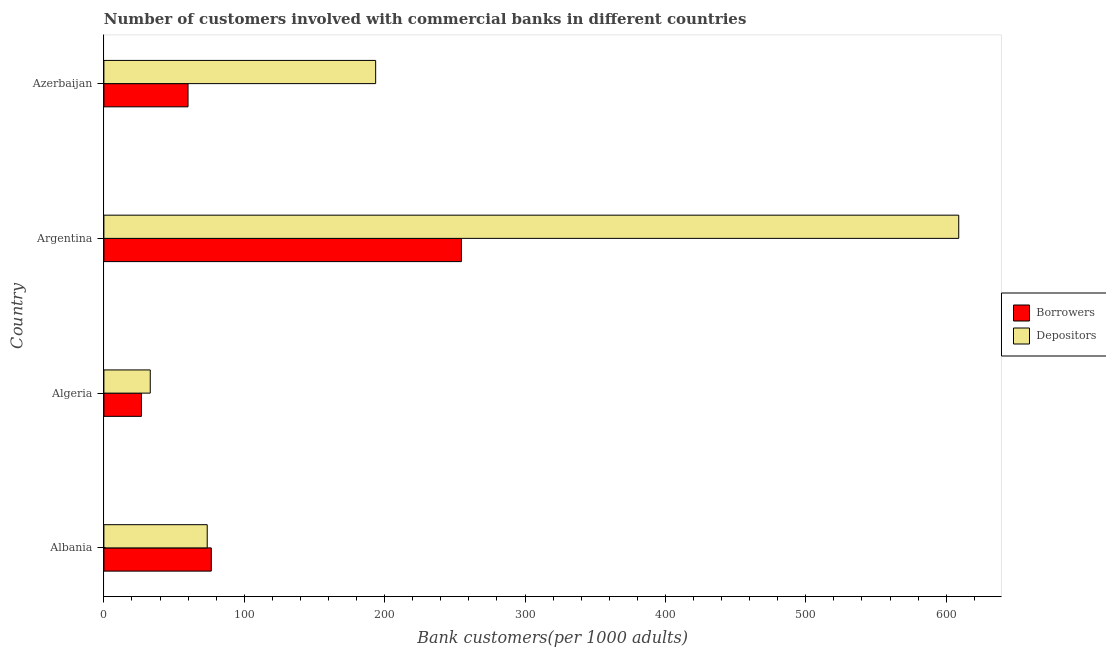How many groups of bars are there?
Your response must be concise. 4. Are the number of bars per tick equal to the number of legend labels?
Make the answer very short. Yes. What is the label of the 1st group of bars from the top?
Your response must be concise. Azerbaijan. What is the number of borrowers in Azerbaijan?
Offer a very short reply. 59.93. Across all countries, what is the maximum number of borrowers?
Offer a terse response. 254.69. Across all countries, what is the minimum number of borrowers?
Offer a terse response. 26.77. In which country was the number of borrowers maximum?
Provide a succinct answer. Argentina. In which country was the number of depositors minimum?
Your response must be concise. Algeria. What is the total number of depositors in the graph?
Your answer should be very brief. 909.13. What is the difference between the number of depositors in Albania and that in Azerbaijan?
Provide a short and direct response. -119.99. What is the difference between the number of borrowers in Albania and the number of depositors in Azerbaijan?
Your response must be concise. -117.09. What is the average number of depositors per country?
Your answer should be very brief. 227.28. What is the difference between the number of borrowers and number of depositors in Azerbaijan?
Offer a very short reply. -133.66. In how many countries, is the number of borrowers greater than 420 ?
Provide a short and direct response. 0. What is the ratio of the number of depositors in Albania to that in Algeria?
Your response must be concise. 2.23. Is the number of borrowers in Argentina less than that in Azerbaijan?
Provide a short and direct response. No. Is the difference between the number of depositors in Algeria and Azerbaijan greater than the difference between the number of borrowers in Algeria and Azerbaijan?
Keep it short and to the point. No. What is the difference between the highest and the second highest number of depositors?
Provide a short and direct response. 415.34. What is the difference between the highest and the lowest number of borrowers?
Offer a very short reply. 227.92. What does the 2nd bar from the top in Argentina represents?
Ensure brevity in your answer.  Borrowers. What does the 2nd bar from the bottom in Albania represents?
Your answer should be very brief. Depositors. How many countries are there in the graph?
Give a very brief answer. 4. Does the graph contain grids?
Offer a terse response. No. How many legend labels are there?
Offer a very short reply. 2. What is the title of the graph?
Your answer should be compact. Number of customers involved with commercial banks in different countries. Does "Travel services" appear as one of the legend labels in the graph?
Your answer should be compact. No. What is the label or title of the X-axis?
Provide a short and direct response. Bank customers(per 1000 adults). What is the Bank customers(per 1000 adults) of Borrowers in Albania?
Your answer should be very brief. 76.5. What is the Bank customers(per 1000 adults) of Depositors in Albania?
Offer a very short reply. 73.6. What is the Bank customers(per 1000 adults) of Borrowers in Algeria?
Offer a terse response. 26.77. What is the Bank customers(per 1000 adults) in Depositors in Algeria?
Provide a short and direct response. 33.02. What is the Bank customers(per 1000 adults) of Borrowers in Argentina?
Keep it short and to the point. 254.69. What is the Bank customers(per 1000 adults) in Depositors in Argentina?
Your response must be concise. 608.93. What is the Bank customers(per 1000 adults) of Borrowers in Azerbaijan?
Keep it short and to the point. 59.93. What is the Bank customers(per 1000 adults) of Depositors in Azerbaijan?
Ensure brevity in your answer.  193.59. Across all countries, what is the maximum Bank customers(per 1000 adults) of Borrowers?
Keep it short and to the point. 254.69. Across all countries, what is the maximum Bank customers(per 1000 adults) in Depositors?
Provide a succinct answer. 608.93. Across all countries, what is the minimum Bank customers(per 1000 adults) of Borrowers?
Provide a short and direct response. 26.77. Across all countries, what is the minimum Bank customers(per 1000 adults) in Depositors?
Provide a succinct answer. 33.02. What is the total Bank customers(per 1000 adults) of Borrowers in the graph?
Your response must be concise. 417.89. What is the total Bank customers(per 1000 adults) of Depositors in the graph?
Your answer should be compact. 909.13. What is the difference between the Bank customers(per 1000 adults) of Borrowers in Albania and that in Algeria?
Give a very brief answer. 49.73. What is the difference between the Bank customers(per 1000 adults) in Depositors in Albania and that in Algeria?
Your answer should be compact. 40.58. What is the difference between the Bank customers(per 1000 adults) in Borrowers in Albania and that in Argentina?
Your answer should be compact. -178.19. What is the difference between the Bank customers(per 1000 adults) in Depositors in Albania and that in Argentina?
Your answer should be very brief. -535.33. What is the difference between the Bank customers(per 1000 adults) in Borrowers in Albania and that in Azerbaijan?
Offer a very short reply. 16.57. What is the difference between the Bank customers(per 1000 adults) in Depositors in Albania and that in Azerbaijan?
Your answer should be very brief. -119.99. What is the difference between the Bank customers(per 1000 adults) of Borrowers in Algeria and that in Argentina?
Offer a very short reply. -227.92. What is the difference between the Bank customers(per 1000 adults) of Depositors in Algeria and that in Argentina?
Give a very brief answer. -575.91. What is the difference between the Bank customers(per 1000 adults) in Borrowers in Algeria and that in Azerbaijan?
Give a very brief answer. -33.16. What is the difference between the Bank customers(per 1000 adults) in Depositors in Algeria and that in Azerbaijan?
Your answer should be compact. -160.57. What is the difference between the Bank customers(per 1000 adults) in Borrowers in Argentina and that in Azerbaijan?
Provide a short and direct response. 194.76. What is the difference between the Bank customers(per 1000 adults) of Depositors in Argentina and that in Azerbaijan?
Your answer should be very brief. 415.34. What is the difference between the Bank customers(per 1000 adults) in Borrowers in Albania and the Bank customers(per 1000 adults) in Depositors in Algeria?
Give a very brief answer. 43.48. What is the difference between the Bank customers(per 1000 adults) in Borrowers in Albania and the Bank customers(per 1000 adults) in Depositors in Argentina?
Provide a short and direct response. -532.43. What is the difference between the Bank customers(per 1000 adults) of Borrowers in Albania and the Bank customers(per 1000 adults) of Depositors in Azerbaijan?
Offer a very short reply. -117.09. What is the difference between the Bank customers(per 1000 adults) of Borrowers in Algeria and the Bank customers(per 1000 adults) of Depositors in Argentina?
Provide a succinct answer. -582.15. What is the difference between the Bank customers(per 1000 adults) of Borrowers in Algeria and the Bank customers(per 1000 adults) of Depositors in Azerbaijan?
Ensure brevity in your answer.  -166.82. What is the difference between the Bank customers(per 1000 adults) of Borrowers in Argentina and the Bank customers(per 1000 adults) of Depositors in Azerbaijan?
Make the answer very short. 61.1. What is the average Bank customers(per 1000 adults) of Borrowers per country?
Keep it short and to the point. 104.47. What is the average Bank customers(per 1000 adults) in Depositors per country?
Provide a succinct answer. 227.28. What is the difference between the Bank customers(per 1000 adults) of Borrowers and Bank customers(per 1000 adults) of Depositors in Albania?
Your response must be concise. 2.9. What is the difference between the Bank customers(per 1000 adults) in Borrowers and Bank customers(per 1000 adults) in Depositors in Algeria?
Ensure brevity in your answer.  -6.25. What is the difference between the Bank customers(per 1000 adults) of Borrowers and Bank customers(per 1000 adults) of Depositors in Argentina?
Make the answer very short. -354.23. What is the difference between the Bank customers(per 1000 adults) of Borrowers and Bank customers(per 1000 adults) of Depositors in Azerbaijan?
Provide a short and direct response. -133.66. What is the ratio of the Bank customers(per 1000 adults) in Borrowers in Albania to that in Algeria?
Make the answer very short. 2.86. What is the ratio of the Bank customers(per 1000 adults) in Depositors in Albania to that in Algeria?
Your answer should be compact. 2.23. What is the ratio of the Bank customers(per 1000 adults) in Borrowers in Albania to that in Argentina?
Provide a succinct answer. 0.3. What is the ratio of the Bank customers(per 1000 adults) in Depositors in Albania to that in Argentina?
Ensure brevity in your answer.  0.12. What is the ratio of the Bank customers(per 1000 adults) in Borrowers in Albania to that in Azerbaijan?
Ensure brevity in your answer.  1.28. What is the ratio of the Bank customers(per 1000 adults) in Depositors in Albania to that in Azerbaijan?
Your answer should be very brief. 0.38. What is the ratio of the Bank customers(per 1000 adults) in Borrowers in Algeria to that in Argentina?
Give a very brief answer. 0.11. What is the ratio of the Bank customers(per 1000 adults) of Depositors in Algeria to that in Argentina?
Your answer should be compact. 0.05. What is the ratio of the Bank customers(per 1000 adults) in Borrowers in Algeria to that in Azerbaijan?
Ensure brevity in your answer.  0.45. What is the ratio of the Bank customers(per 1000 adults) in Depositors in Algeria to that in Azerbaijan?
Give a very brief answer. 0.17. What is the ratio of the Bank customers(per 1000 adults) in Borrowers in Argentina to that in Azerbaijan?
Ensure brevity in your answer.  4.25. What is the ratio of the Bank customers(per 1000 adults) of Depositors in Argentina to that in Azerbaijan?
Your answer should be compact. 3.15. What is the difference between the highest and the second highest Bank customers(per 1000 adults) in Borrowers?
Give a very brief answer. 178.19. What is the difference between the highest and the second highest Bank customers(per 1000 adults) of Depositors?
Keep it short and to the point. 415.34. What is the difference between the highest and the lowest Bank customers(per 1000 adults) of Borrowers?
Your answer should be compact. 227.92. What is the difference between the highest and the lowest Bank customers(per 1000 adults) in Depositors?
Offer a very short reply. 575.91. 